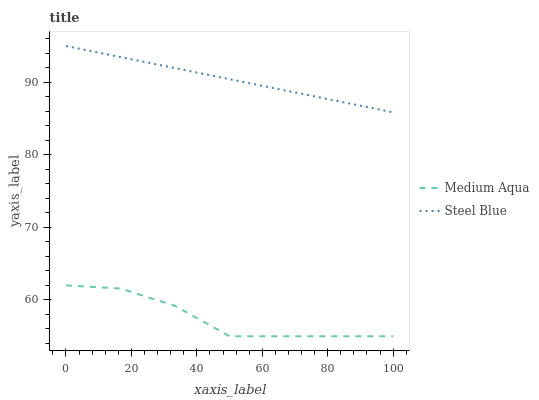Does Medium Aqua have the minimum area under the curve?
Answer yes or no. Yes. Does Steel Blue have the maximum area under the curve?
Answer yes or no. Yes. Does Steel Blue have the minimum area under the curve?
Answer yes or no. No. Is Steel Blue the smoothest?
Answer yes or no. Yes. Is Medium Aqua the roughest?
Answer yes or no. Yes. Is Steel Blue the roughest?
Answer yes or no. No. Does Medium Aqua have the lowest value?
Answer yes or no. Yes. Does Steel Blue have the lowest value?
Answer yes or no. No. Does Steel Blue have the highest value?
Answer yes or no. Yes. Is Medium Aqua less than Steel Blue?
Answer yes or no. Yes. Is Steel Blue greater than Medium Aqua?
Answer yes or no. Yes. Does Medium Aqua intersect Steel Blue?
Answer yes or no. No. 